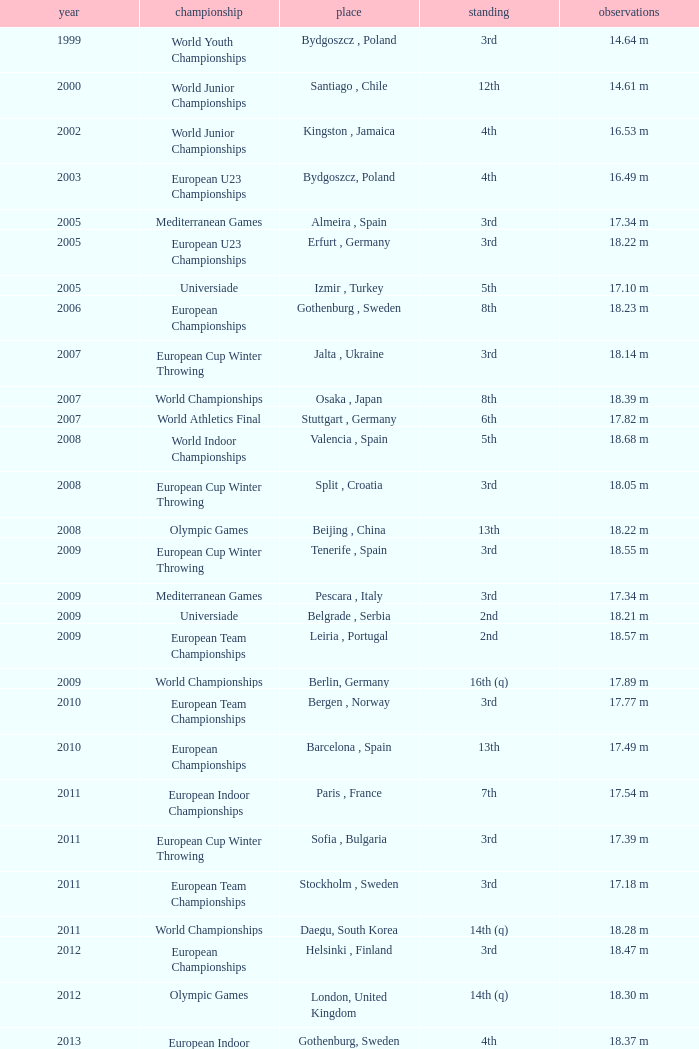What position is 1999? 3rd. 